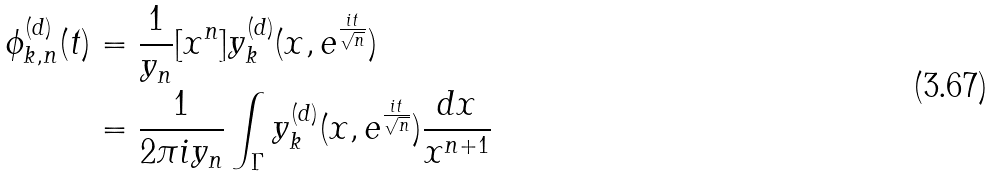<formula> <loc_0><loc_0><loc_500><loc_500>\phi _ { k , n } ^ { ( d ) } ( t ) & = \frac { 1 } { y _ { n } } [ x ^ { n } ] y _ { k } ^ { ( d ) } ( x , e ^ { \frac { i t } { \sqrt { n } } } ) \\ & = \frac { 1 } { 2 \pi i y _ { n } } \int _ { \Gamma } y _ { k } ^ { ( d ) } ( x , e ^ { \frac { i t } { \sqrt { n } } } ) \frac { d x } { x ^ { n + 1 } }</formula> 